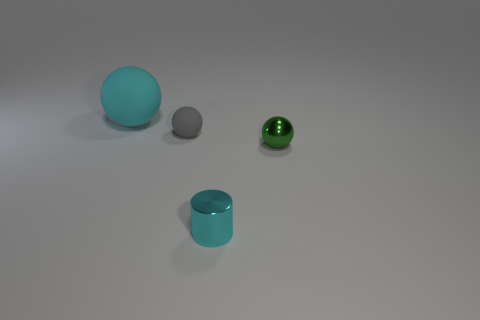Do the cyan metal thing and the gray object have the same size?
Provide a succinct answer. Yes. Is there a tiny metal sphere that has the same color as the tiny metal cylinder?
Your answer should be very brief. No. There is a cyan thing behind the metal cylinder; is its shape the same as the small gray thing?
Your response must be concise. Yes. How many green objects have the same size as the cyan metallic cylinder?
Provide a short and direct response. 1. There is a matte ball that is right of the large cyan rubber sphere; how many cyan objects are left of it?
Ensure brevity in your answer.  1. Do the cyan thing to the right of the large cyan matte ball and the large cyan ball have the same material?
Keep it short and to the point. No. Is the material of the cyan thing on the right side of the big rubber thing the same as the cyan object to the left of the small metallic cylinder?
Make the answer very short. No. Are there more tiny things behind the tiny cylinder than tiny green metal things?
Provide a short and direct response. Yes. There is a thing in front of the metallic sphere that is on the right side of the big cyan thing; what color is it?
Give a very brief answer. Cyan. What shape is the gray thing that is the same size as the cyan cylinder?
Your response must be concise. Sphere. 